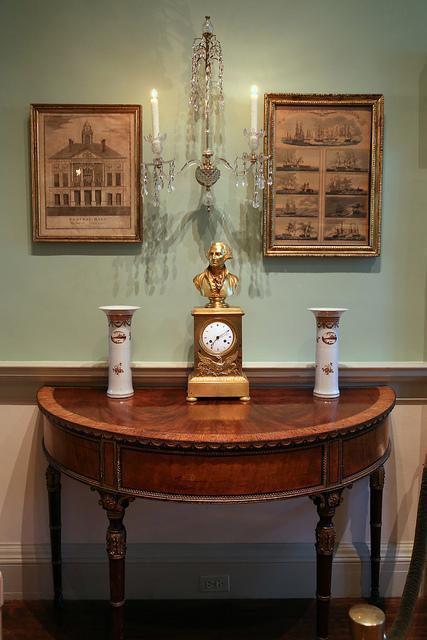How many vases are there?
Give a very brief answer. 2. 